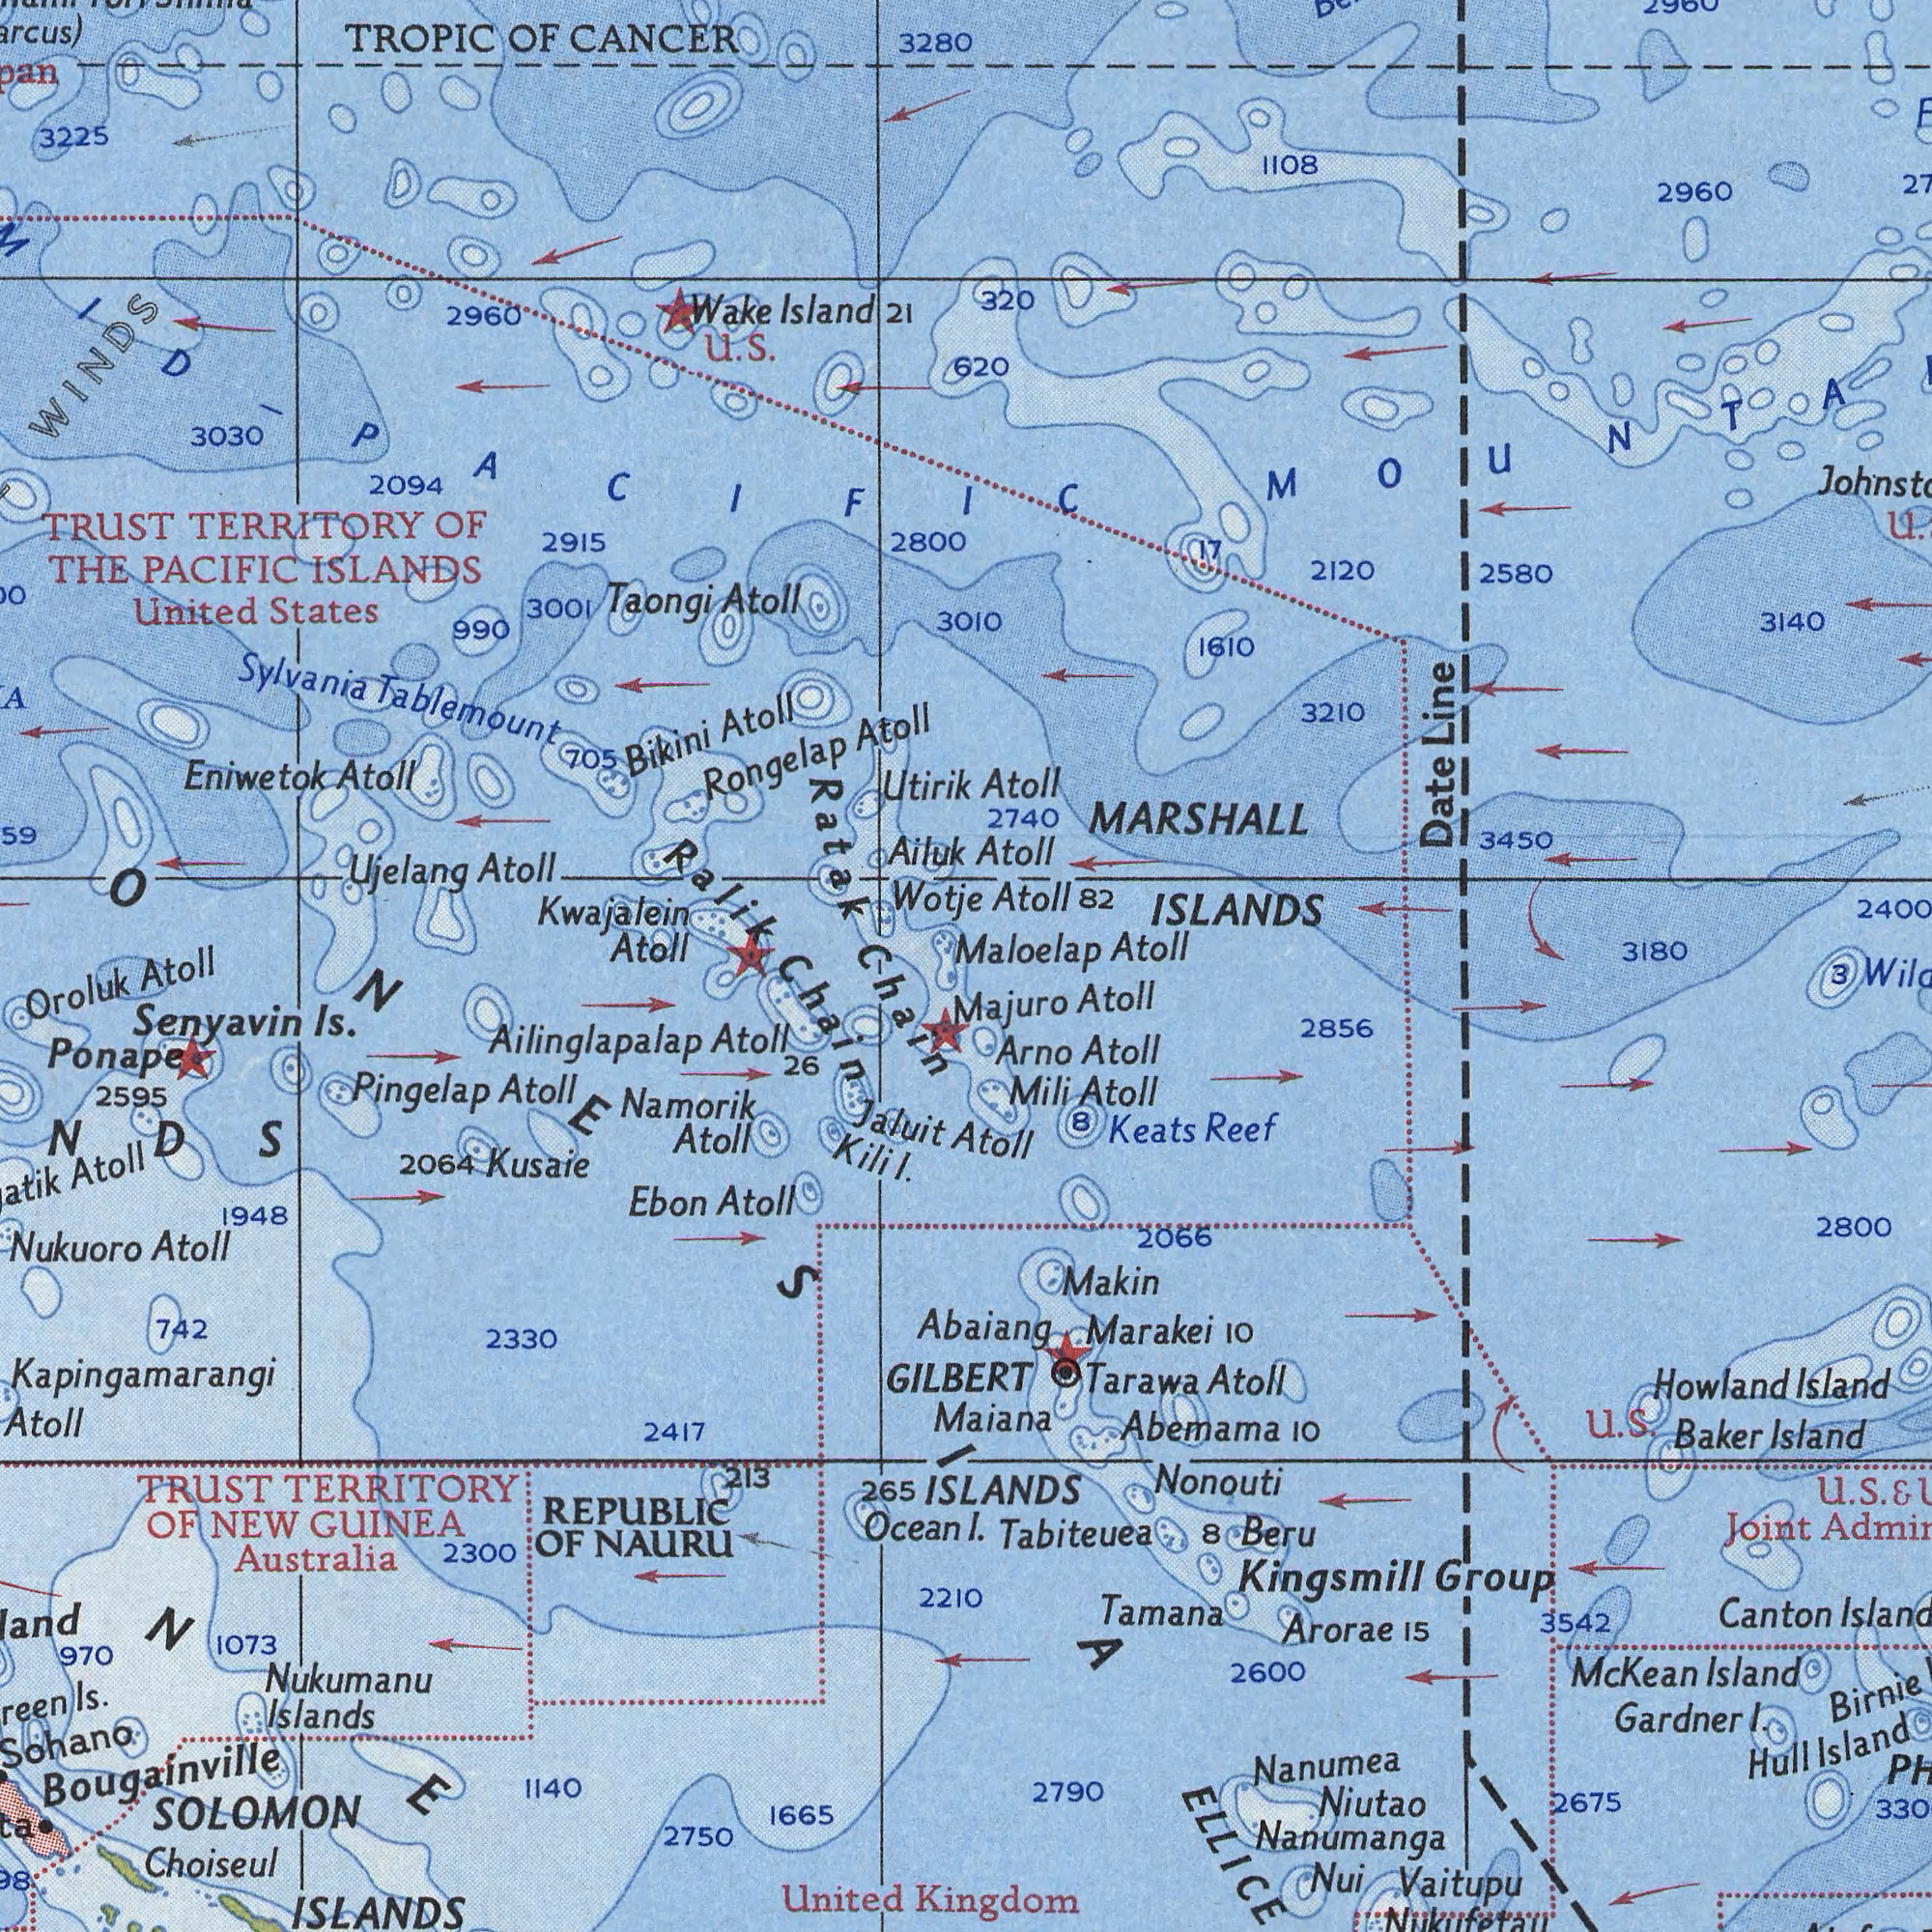What text is visible in the upper-left corner? Kwajalein Atoll Rongelap Atoll Eniwetok Atoll TRUST TERRITORY OF THE PACIFIC ISLANDS TROPIC OF CANCER Sylvania Tablemount Ujelang Atoll United States Wotje Bikini Atoll Taongi Atoll 2094 3001 3030 Ailuk Utirik 2800 3280 2960 990 Ralik Wake Island 21 Ratak 3225 705 WINDS 2915 U. S. What text is shown in the top-right quadrant? Atoll 82 Atoll Atoll 3010 MARSHALL ISLANDS Maloelap Atoll 3450 2960 3180 3140 2120 2400 2740 3210 1610 Date Line u. 2580 1108 320 620 17 2960 What text is visible in the lower-left corner? Chain Chain SOLOMON ISLANDS Senyavin Is. Nukuoro Atoll REPUBLIC OF NAURU United Nukumanu Islands Namorik Atoll TRUST TERRITORY OF NEW GUINEA Australia Ponape Choiseul Kusaie Atoll 1665 GILBERT Oroluk Atoll Ebon Atoll 2750 Pingelap Atoll Ocean 2064 1073 265 Kapingamarangi Atoll 1948 2417 Ailinglapalap Atoll 2330 2595 1140 2300 742 213 2210 970 26 Bougainville Jaluit Is. Kili I. What text is shown in the bottom-right quadrant? Kingdom ISLANDS I. Abaiang Atoll Maiana ELLICE Nanumea Nanumanga Arno Atoll Abemama 10 Tabiteuea Niutao Makin Mili Atoll 2790 Nonouti 2800 Joint Beru Arorae 15 3542 Kingsmill Group Tarawa Atoll 2856 Birnie Tamana Majuro Atoll Baker Island Marakei 10 2600 2675 Keats Reef Gardner I. Vaitupu Nukufetau 2066 Nui Canton Hull Island 8 Mc Kean Island 3 U. S. 8 Howland Island U. S. & 